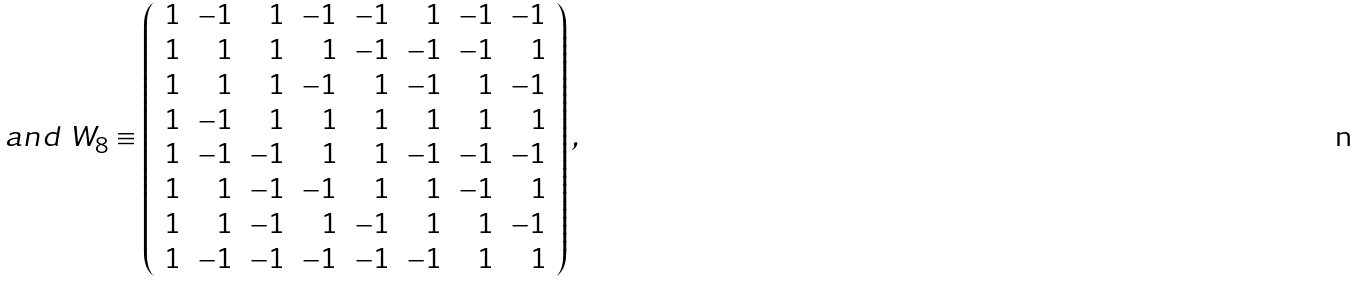Convert formula to latex. <formula><loc_0><loc_0><loc_500><loc_500>a n d \ W _ { 8 } \equiv \left ( \begin{array} { r r r r r r r r } 1 & - 1 & 1 & - 1 & - 1 & 1 & - 1 & - 1 \\ 1 & 1 & 1 & 1 & - 1 & - 1 & - 1 & 1 \\ 1 & 1 & 1 & - 1 & 1 & - 1 & 1 & - 1 \\ 1 & - 1 & 1 & 1 & 1 & 1 & 1 & 1 \\ 1 & - 1 & - 1 & 1 & 1 & - 1 & - 1 & - 1 \\ 1 & 1 & - 1 & - 1 & 1 & 1 & - 1 & 1 \\ 1 & 1 & - 1 & 1 & - 1 & 1 & 1 & - 1 \\ 1 & - 1 & - 1 & - 1 & - 1 & - 1 & 1 & 1 \end{array} \right ) ,</formula> 